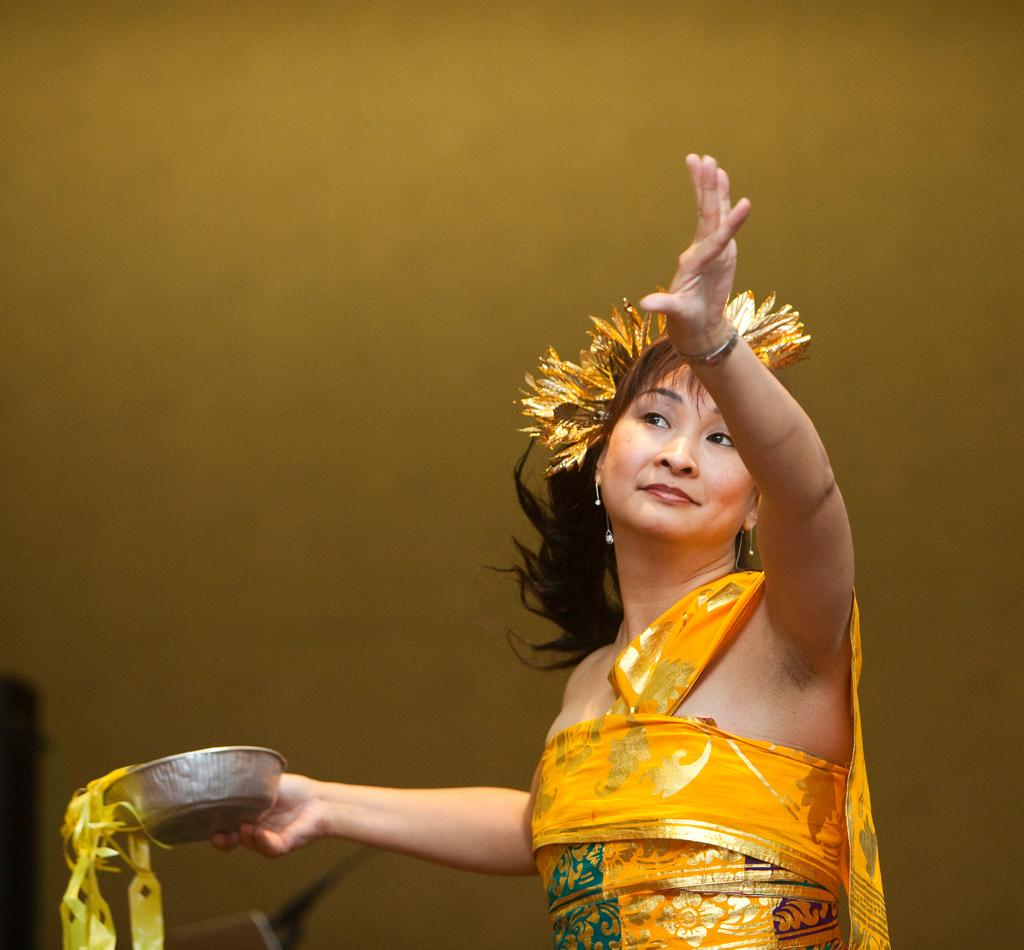Who is present in the image? There is a woman in the image. What is the woman holding in the image? The woman is holding a bowl with her hand. What can be seen in the background of the image? There is a wall in the background of the image. What type of cub is visible in the image? There is no cub present in the image. How does the woman express her love in the image? The image does not show the woman expressing love, so it cannot be determined from the image. 